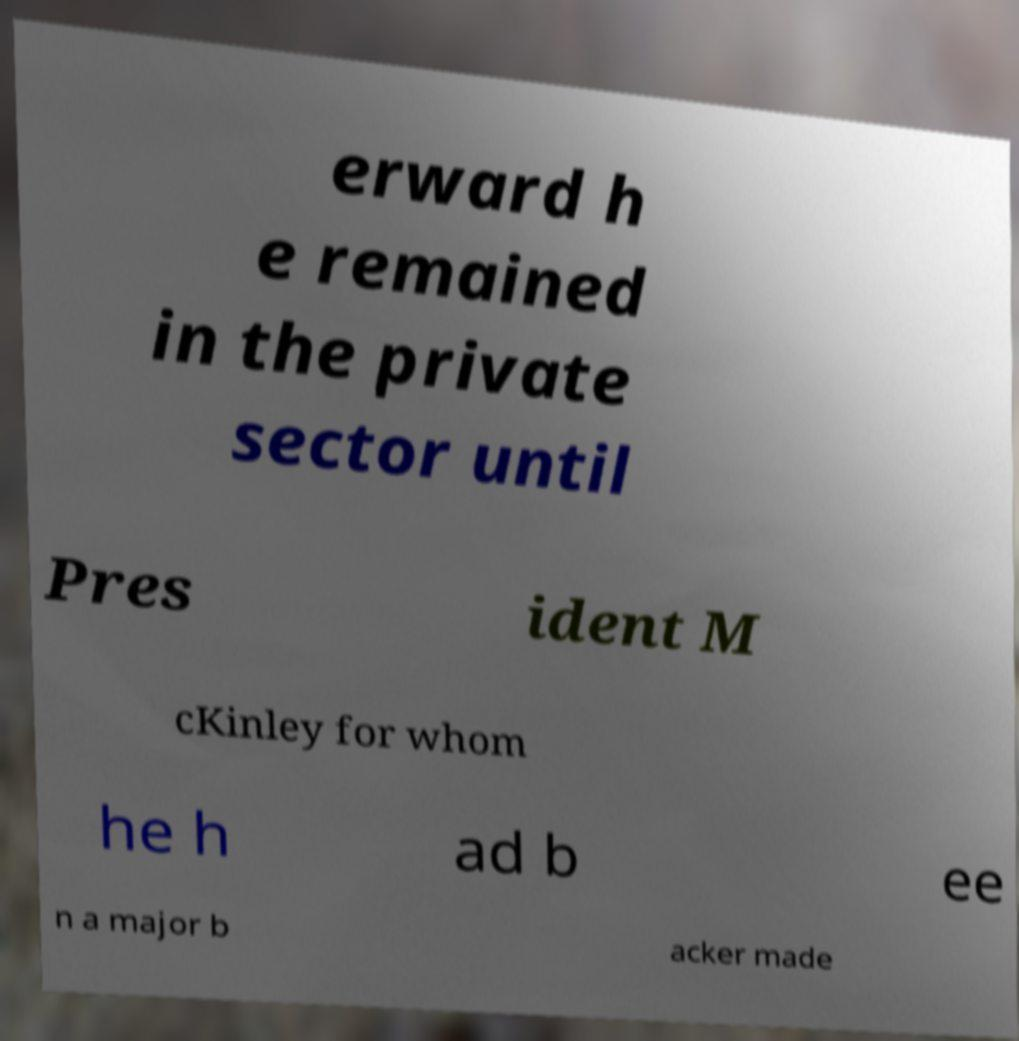Can you accurately transcribe the text from the provided image for me? erward h e remained in the private sector until Pres ident M cKinley for whom he h ad b ee n a major b acker made 